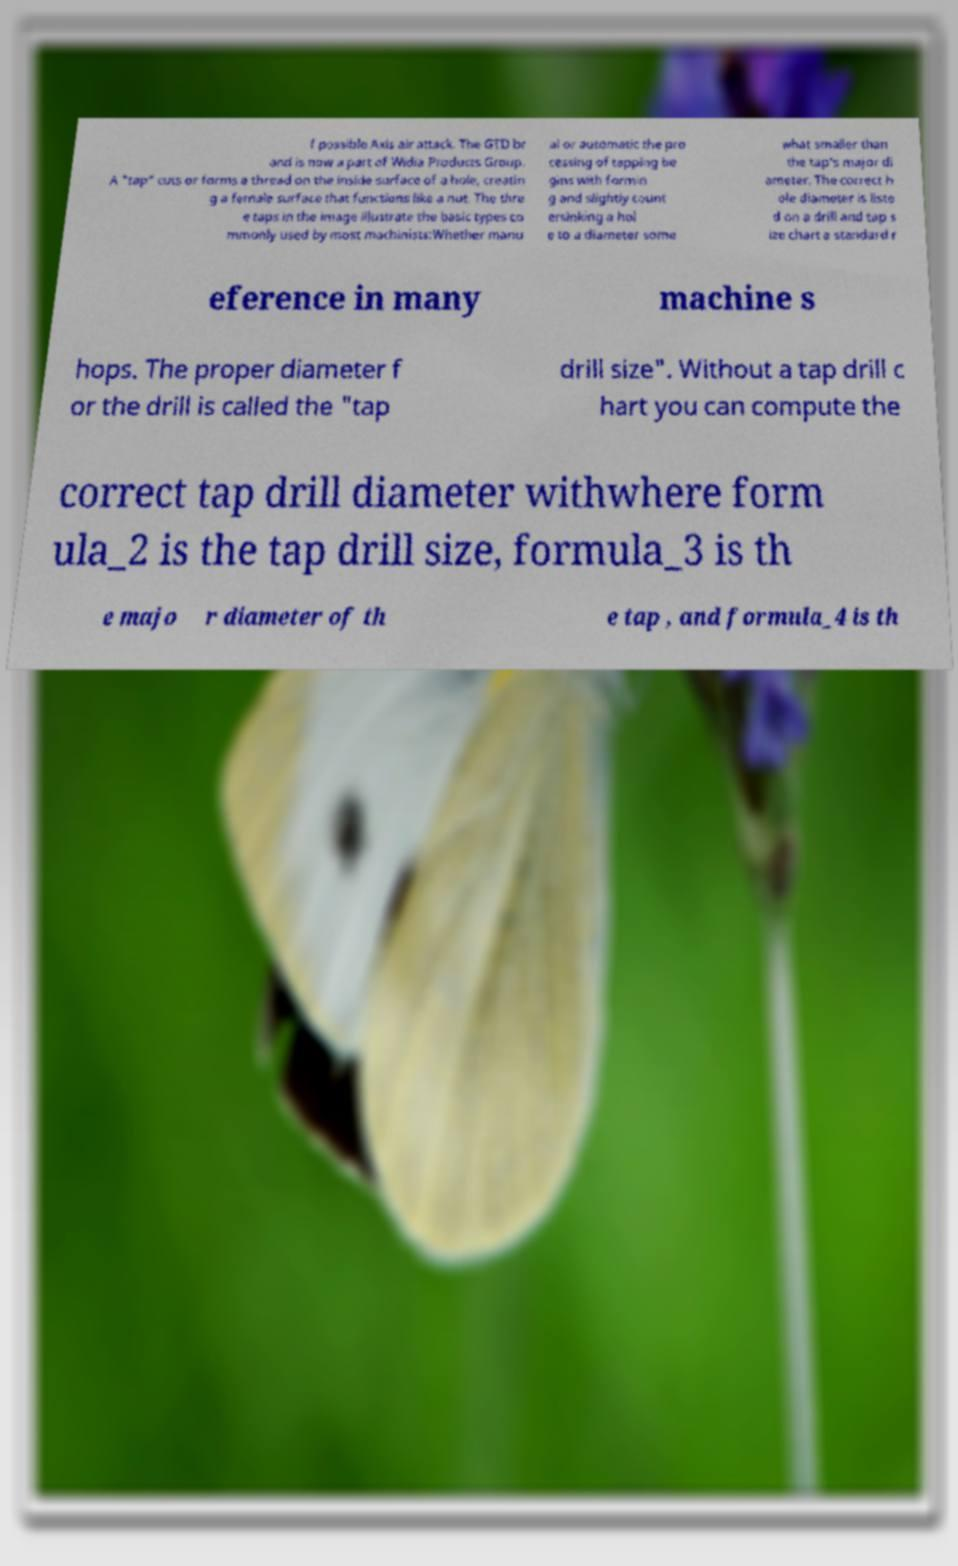I need the written content from this picture converted into text. Can you do that? f possible Axis air attack. The GTD br and is now a part of Widia Products Group. A "tap" cuts or forms a thread on the inside surface of a hole, creatin g a female surface that functions like a nut. The thre e taps in the image illustrate the basic types co mmonly used by most machinists:Whether manu al or automatic the pro cessing of tapping be gins with formin g and slightly count ersinking a hol e to a diameter some what smaller than the tap's major di ameter. The correct h ole diameter is liste d on a drill and tap s ize chart a standard r eference in many machine s hops. The proper diameter f or the drill is called the "tap drill size". Without a tap drill c hart you can compute the correct tap drill diameter withwhere form ula_2 is the tap drill size, formula_3 is th e majo r diameter of th e tap , and formula_4 is th 